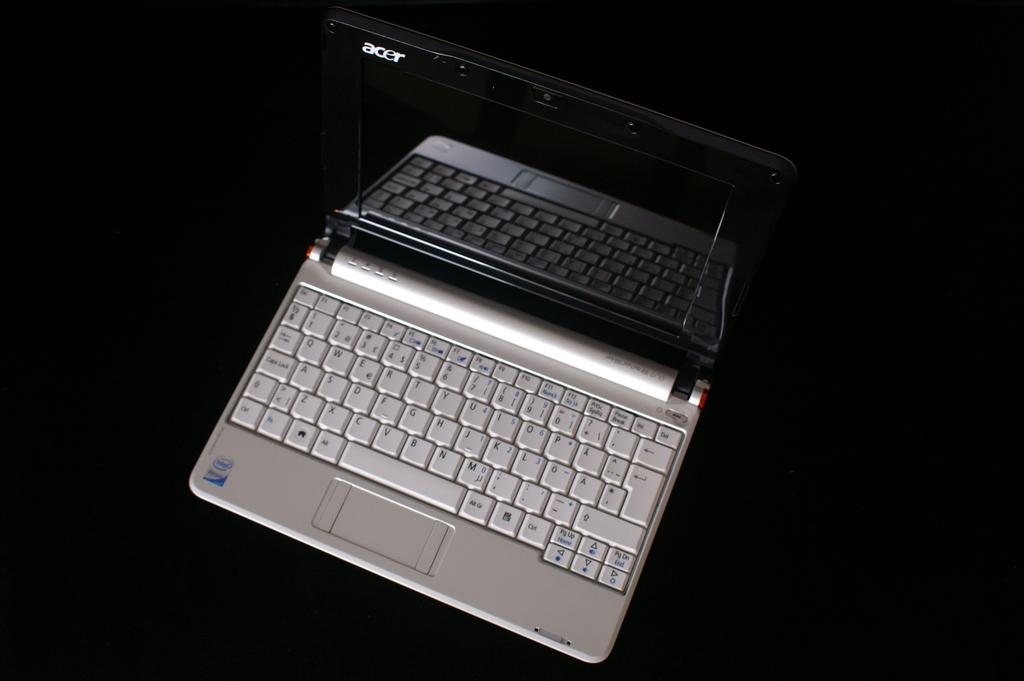Who made this laptop?
Keep it short and to the point. Acer. Does this keyboard have an a key?
Keep it short and to the point. Yes. 